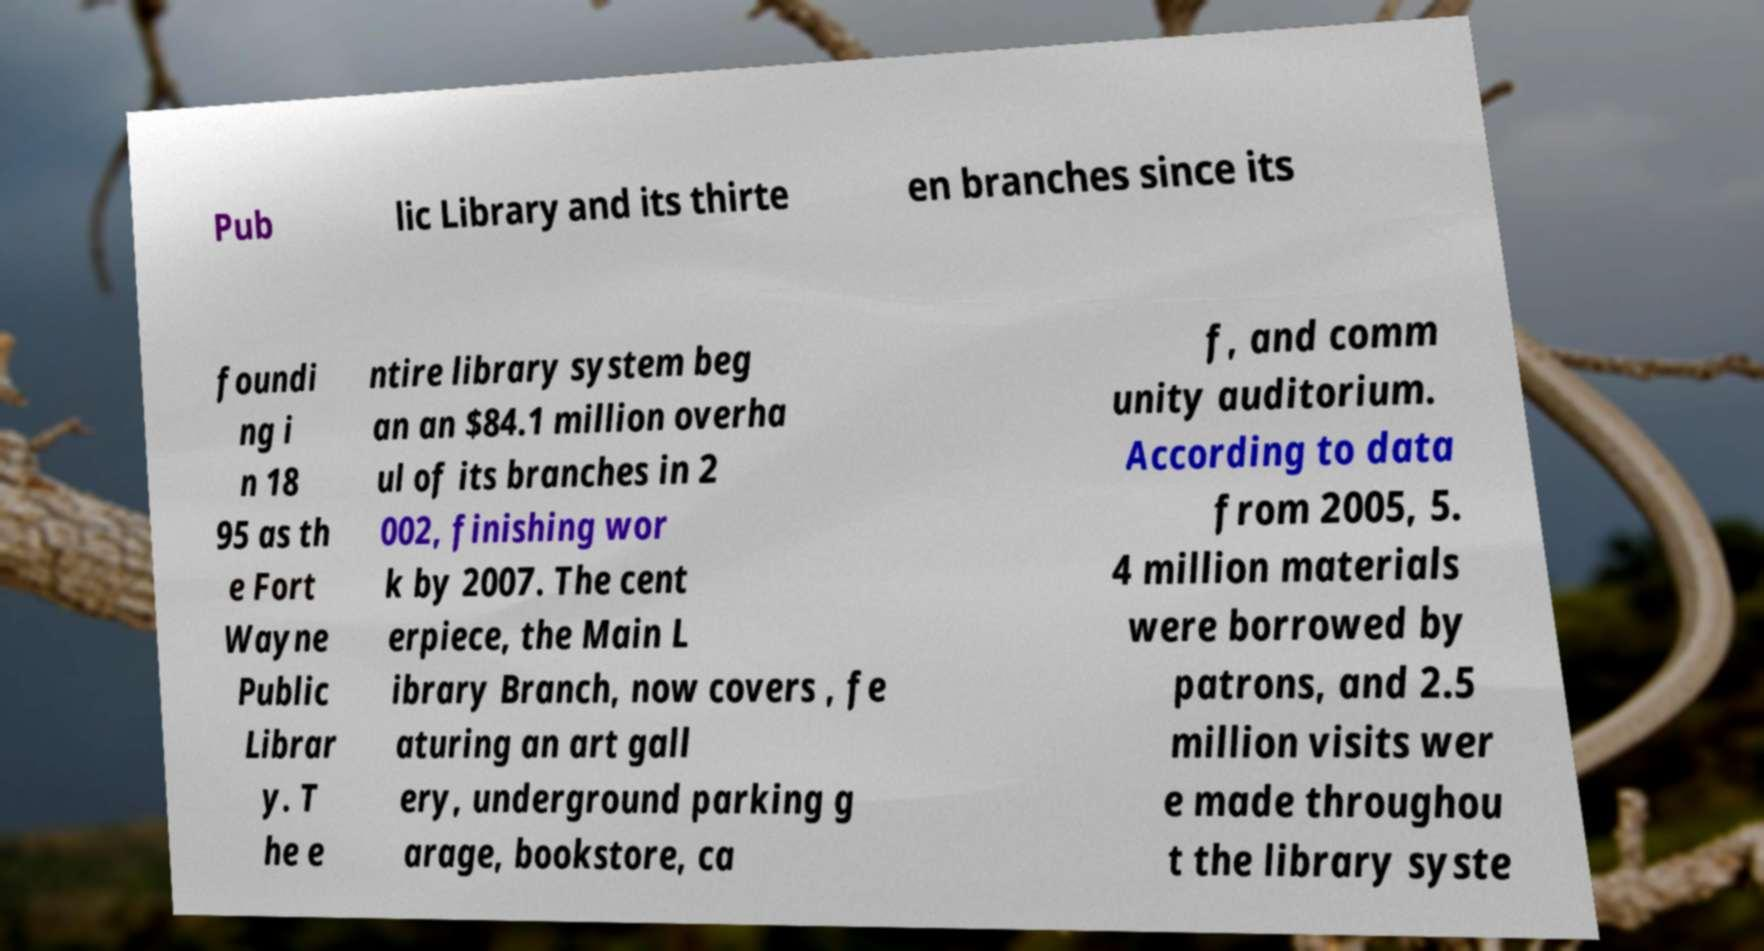Could you assist in decoding the text presented in this image and type it out clearly? Pub lic Library and its thirte en branches since its foundi ng i n 18 95 as th e Fort Wayne Public Librar y. T he e ntire library system beg an an $84.1 million overha ul of its branches in 2 002, finishing wor k by 2007. The cent erpiece, the Main L ibrary Branch, now covers , fe aturing an art gall ery, underground parking g arage, bookstore, ca f, and comm unity auditorium. According to data from 2005, 5. 4 million materials were borrowed by patrons, and 2.5 million visits wer e made throughou t the library syste 